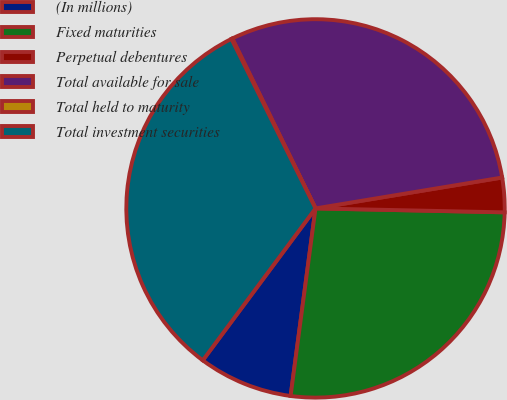<chart> <loc_0><loc_0><loc_500><loc_500><pie_chart><fcel>(In millions)<fcel>Fixed maturities<fcel>Perpetual debentures<fcel>Total available for sale<fcel>Total held to maturity<fcel>Total investment securities<nl><fcel>8.06%<fcel>26.77%<fcel>2.94%<fcel>29.64%<fcel>0.08%<fcel>32.51%<nl></chart> 